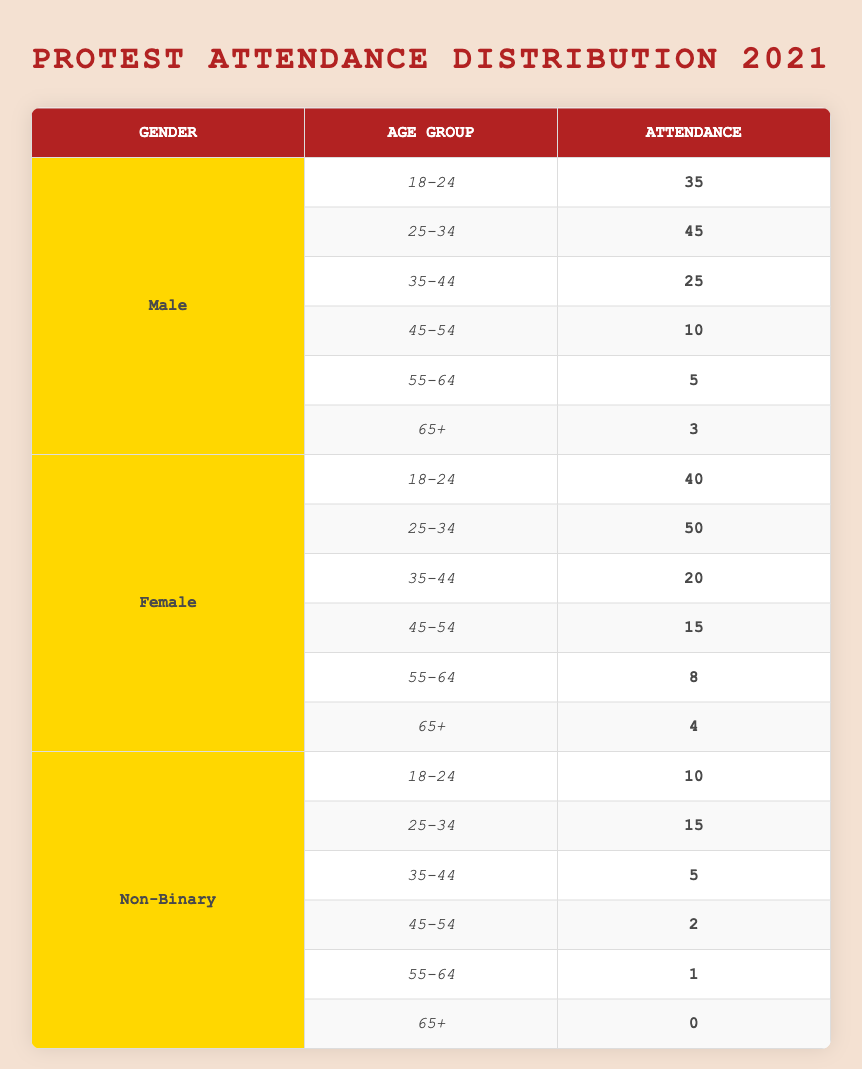What is the total protest attendance for males aged 25-34? The table indicates that the attendance for males aged 25-34 is 45. Therefore, the total protest attendance for this age group is simply that value.
Answer: 45 What was the attendance of females aged 45-54? The table specifies that the attendance for females aged 45-54 is 15. Thus, the answer is directly obtained from this information.
Answer: 15 Is the attendance of non-binary individuals in the age group 65+ greater than the attendance of males in the same age group? The table shows that non-binary individuals aged 65+ have an attendance of 0, while males in the same age group have an attendance of 3. Since 0 is not greater than 3, the answer is no.
Answer: No What age group had the highest protest attendance among females in 2021? By reviewing the female attendance data, the age group with the highest attendance is 25-34 with 50 attendees. This is the highest value compared to other age groups listed for females.
Answer: Age Group 25-34 What is the total attendance for non-binary individuals across all age groups? To find the total attendance for non-binary individuals, we add the attendance values: 10 (18-24) + 15 (25-34) + 5 (35-44) + 2 (45-54) + 1 (55-64) + 0 (65+) = 33. Thus, the total attendance is found by summing these individual figures.
Answer: 33 Which gender and age group combination had the lowest protest attendance? By inspecting the table, we see that the lowest attendance is 0 for non-binary individuals aged 65+. Therefore, that is the answer to the question regarding the lowest attendance.
Answer: Non-Binary, Age Group 65+ What is the difference in protest attendance between males aged 18-24 and females aged 18-24? The attendance figures are 35 for males and 40 for females. The difference is calculated by subtracting males' attendance from females', which is 40 - 35 = 5. Therefore, the answer is obtained through this subtraction.
Answer: 5 What is the average attendance for males across all age groups? To find the average attendance for males, first, we sum their attendance: 35 + 45 + 25 + 10 + 5 + 3 = 123. Next, we divide by the total number of age groups (6), giving us 123 / 6 = 20.5. This is the average attendance for males.
Answer: 20.5 